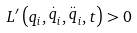Convert formula to latex. <formula><loc_0><loc_0><loc_500><loc_500>L ^ { \prime } \left ( q _ { i } , \stackrel { . } { q } _ { i } , \stackrel { . . } { q } _ { i } , t \right ) > 0</formula> 